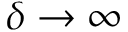Convert formula to latex. <formula><loc_0><loc_0><loc_500><loc_500>\delta \rightarrow \infty</formula> 